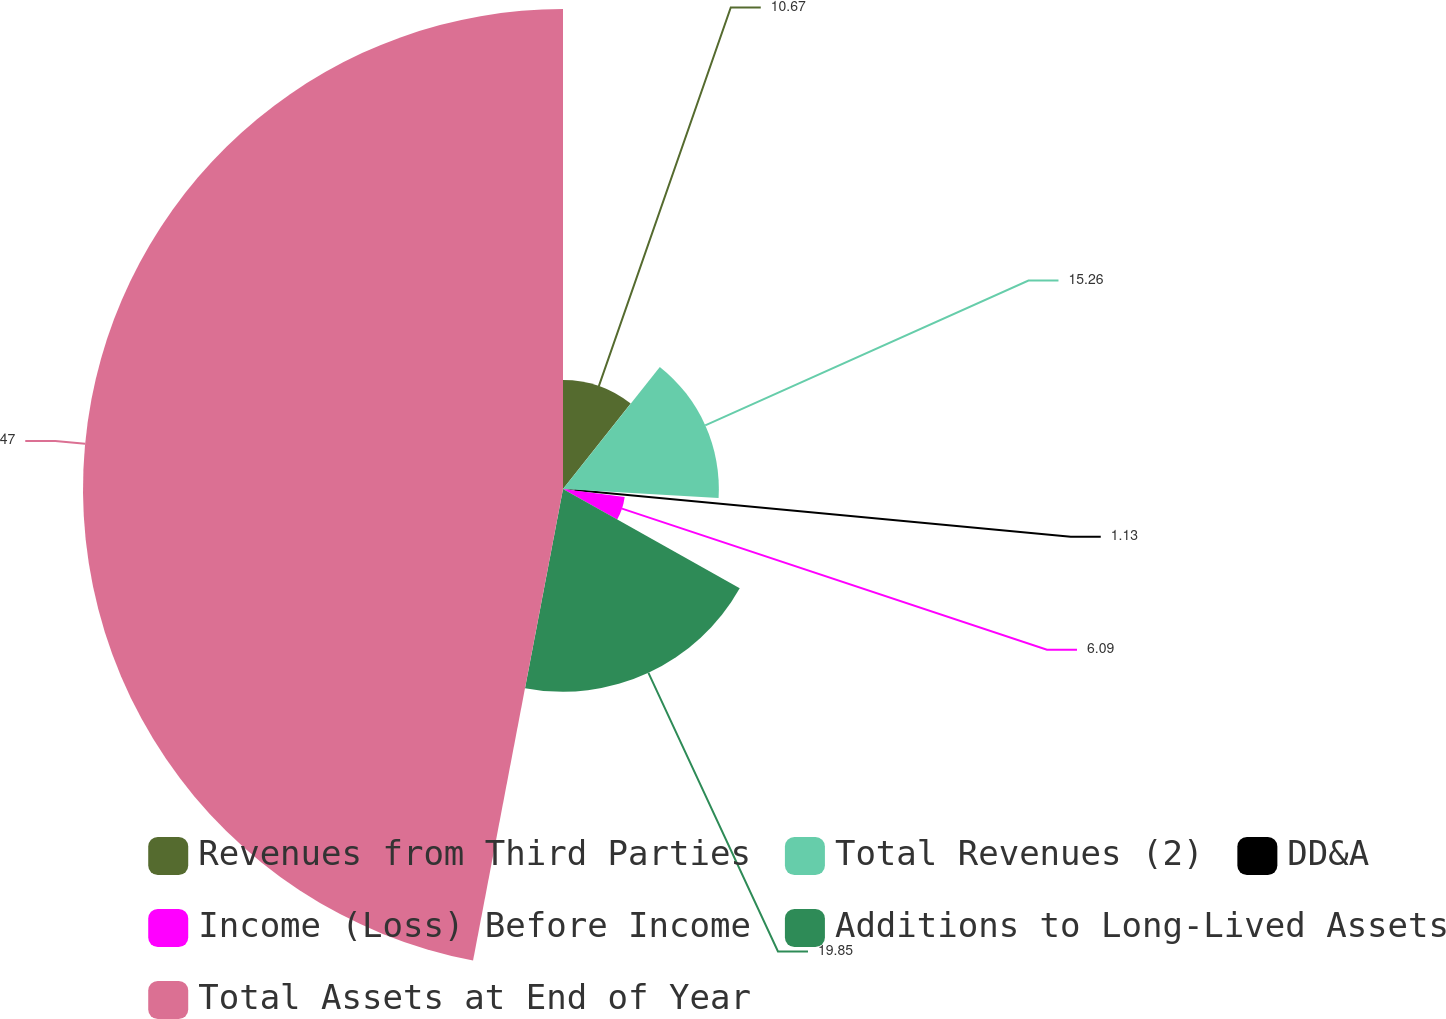<chart> <loc_0><loc_0><loc_500><loc_500><pie_chart><fcel>Revenues from Third Parties<fcel>Total Revenues (2)<fcel>DD&A<fcel>Income (Loss) Before Income<fcel>Additions to Long-Lived Assets<fcel>Total Assets at End of Year<nl><fcel>10.67%<fcel>15.26%<fcel>1.13%<fcel>6.09%<fcel>19.85%<fcel>47.0%<nl></chart> 